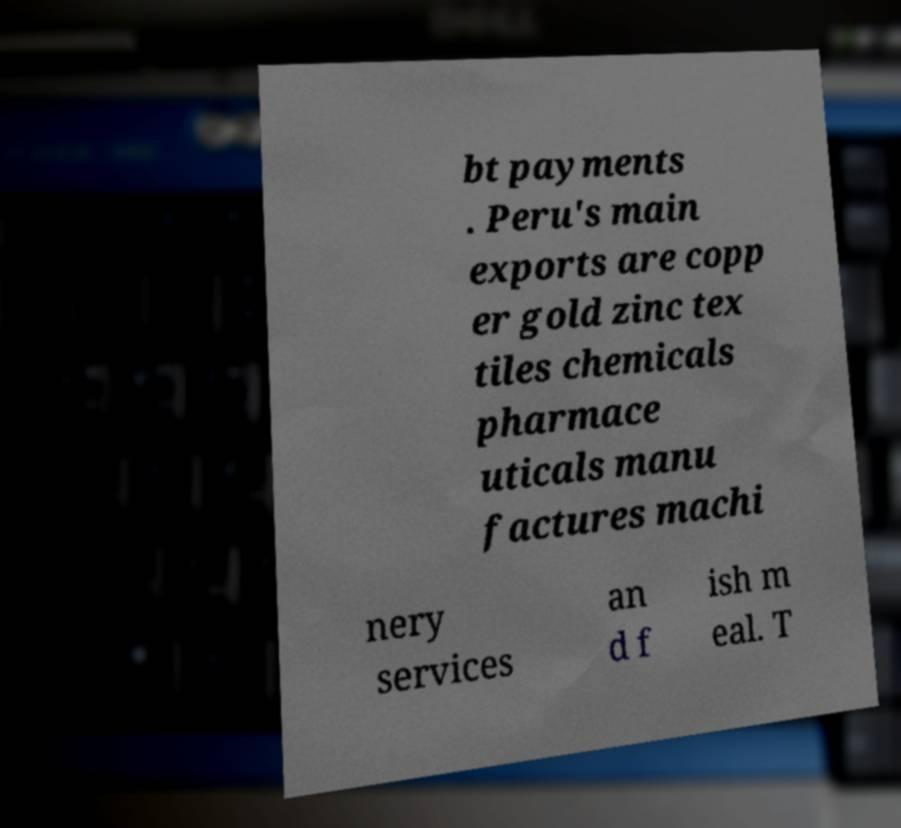There's text embedded in this image that I need extracted. Can you transcribe it verbatim? bt payments . Peru's main exports are copp er gold zinc tex tiles chemicals pharmace uticals manu factures machi nery services an d f ish m eal. T 